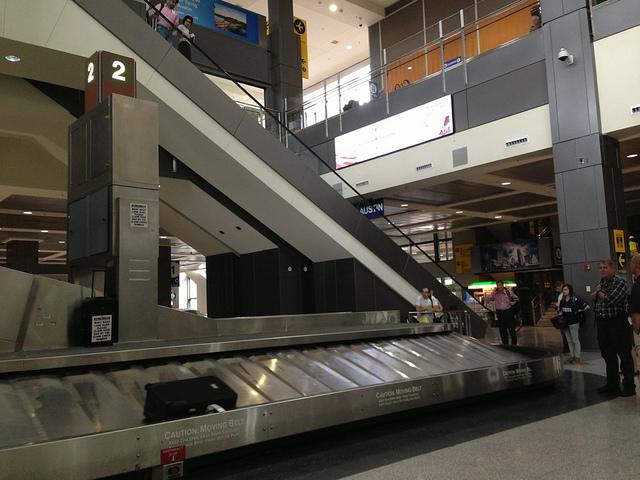What are the people waiting for?
Concise answer only. Luggage. What number is the top of the column?
Give a very brief answer. 2. Where are the passengers?
Write a very short answer. Waiting. What mode of transportation is being shown?
Answer briefly. Escalator. What are they waiting for?
Concise answer only. Luggage. Where is this picture taken?
Short answer required. Airport. Where is this photo taken?
Keep it brief. Airport. What is the yellow line for?
Answer briefly. Do not cross. Is this an aerial view photo?
Give a very brief answer. No. 